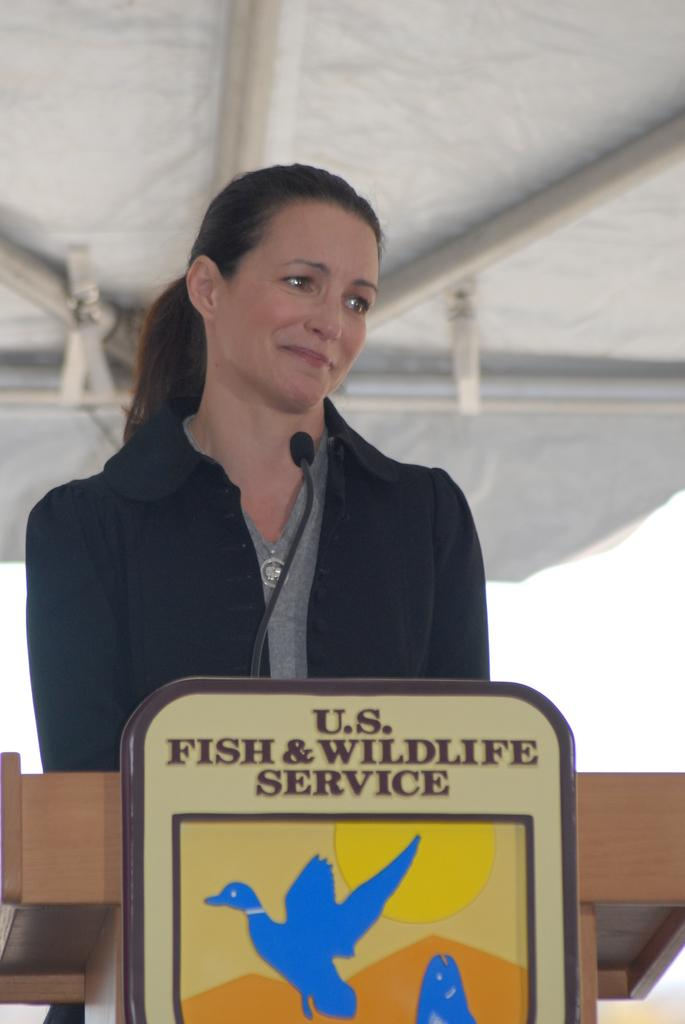<image>
Relay a brief, clear account of the picture shown. A speaker from the U.S. Fish & Wildlife Service is at the podium. 